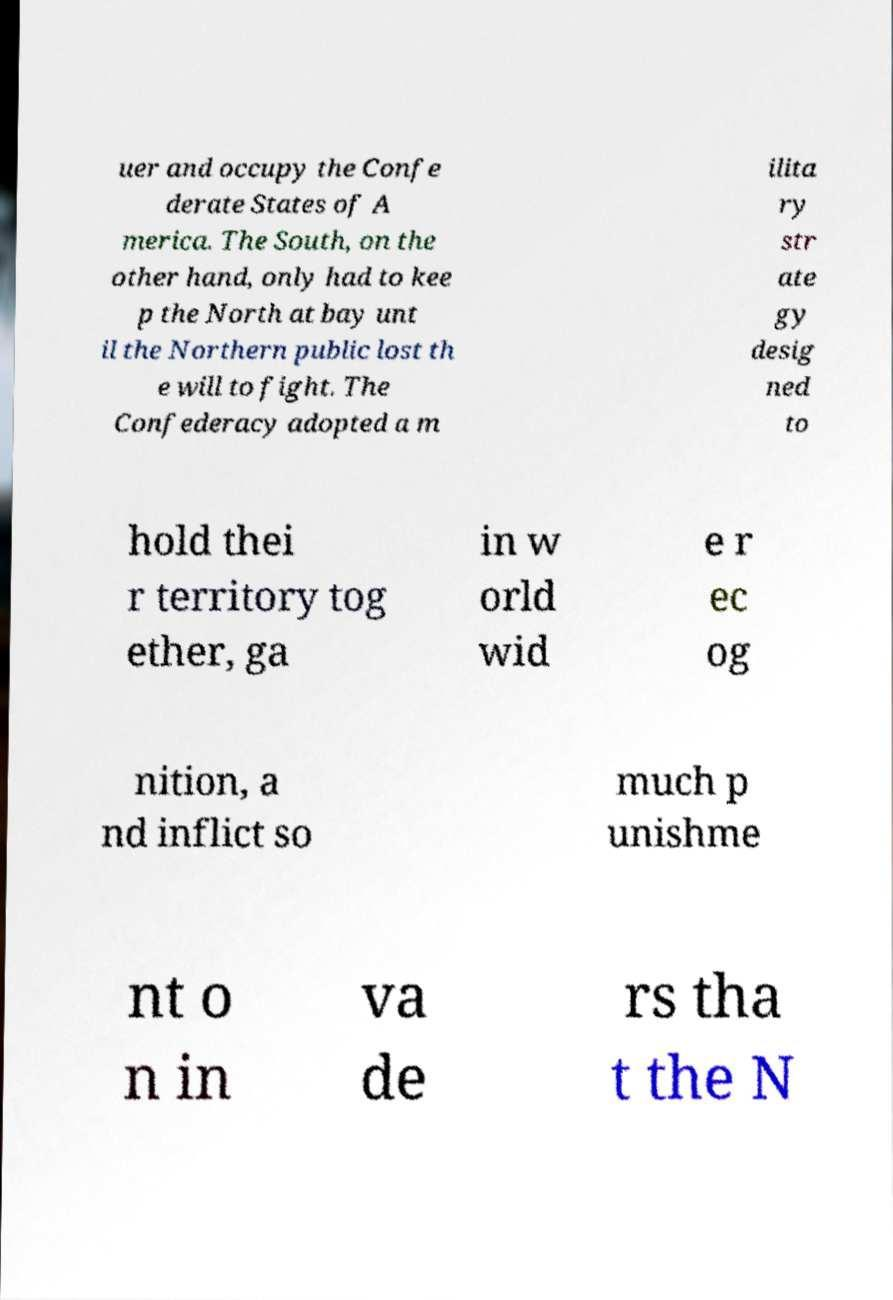Could you assist in decoding the text presented in this image and type it out clearly? uer and occupy the Confe derate States of A merica. The South, on the other hand, only had to kee p the North at bay unt il the Northern public lost th e will to fight. The Confederacy adopted a m ilita ry str ate gy desig ned to hold thei r territory tog ether, ga in w orld wid e r ec og nition, a nd inflict so much p unishme nt o n in va de rs tha t the N 